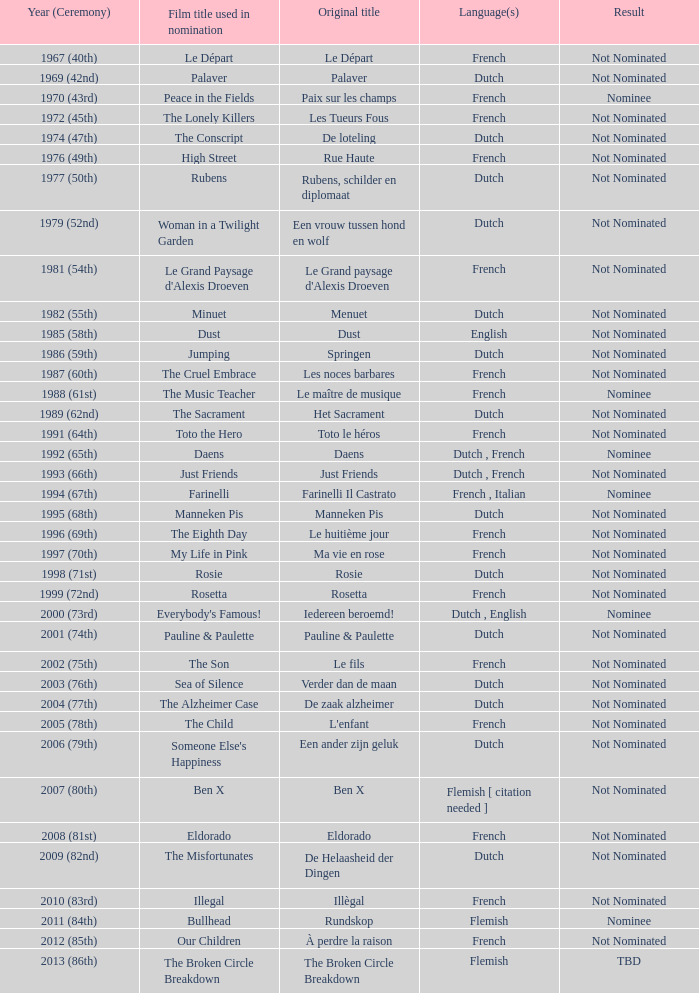What was the title used for Rosie, the film nominated for the dutch language? Rosie. 